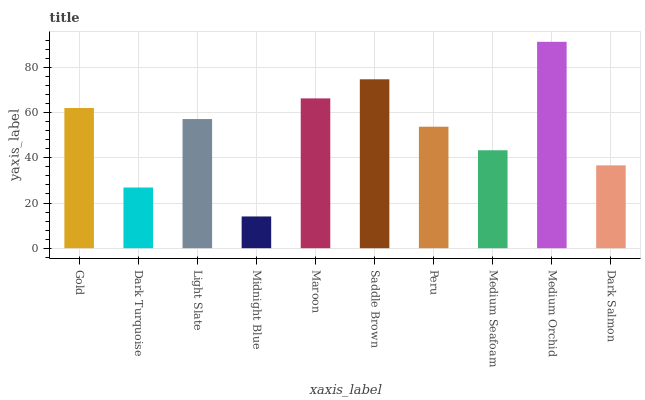Is Midnight Blue the minimum?
Answer yes or no. Yes. Is Medium Orchid the maximum?
Answer yes or no. Yes. Is Dark Turquoise the minimum?
Answer yes or no. No. Is Dark Turquoise the maximum?
Answer yes or no. No. Is Gold greater than Dark Turquoise?
Answer yes or no. Yes. Is Dark Turquoise less than Gold?
Answer yes or no. Yes. Is Dark Turquoise greater than Gold?
Answer yes or no. No. Is Gold less than Dark Turquoise?
Answer yes or no. No. Is Light Slate the high median?
Answer yes or no. Yes. Is Peru the low median?
Answer yes or no. Yes. Is Saddle Brown the high median?
Answer yes or no. No. Is Gold the low median?
Answer yes or no. No. 